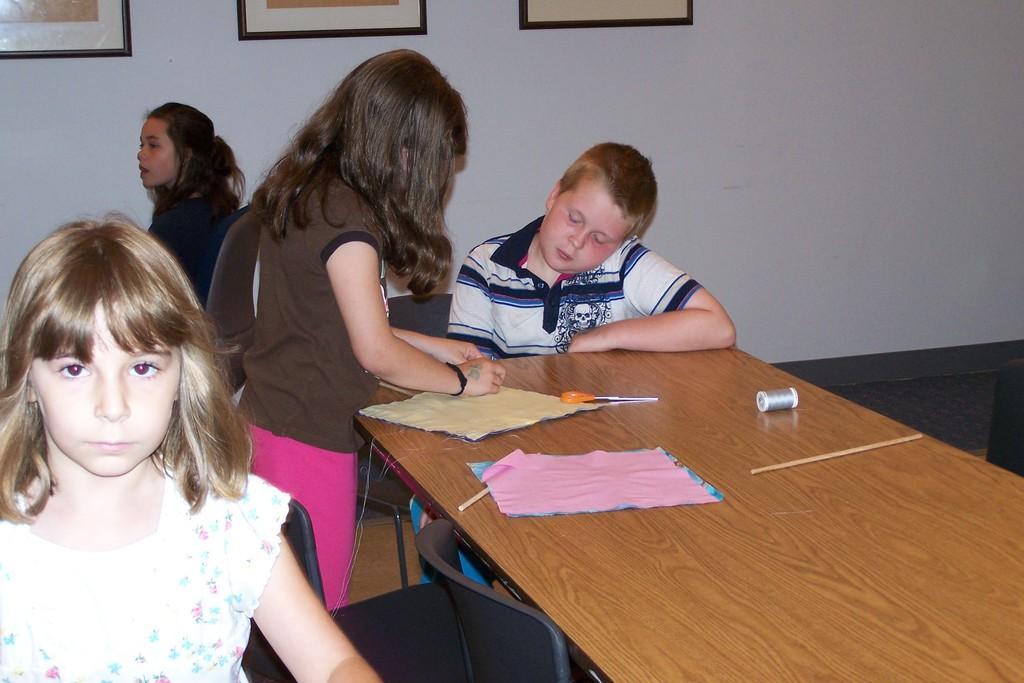Can you describe this image briefly? In the picture we can find three girls and one boy, the boy is sitting in the chair near to the table and one girl is standing near the table and writing something on the cloth, background we can find the wall and photos. 